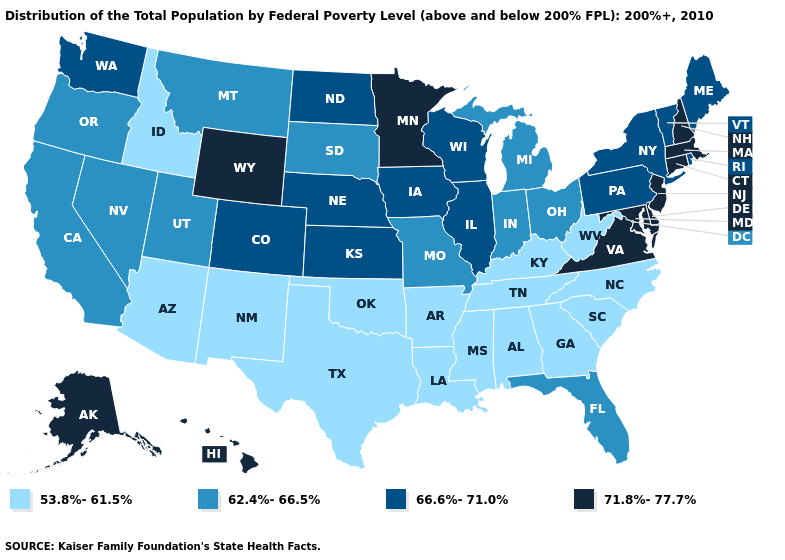Name the states that have a value in the range 66.6%-71.0%?
Give a very brief answer. Colorado, Illinois, Iowa, Kansas, Maine, Nebraska, New York, North Dakota, Pennsylvania, Rhode Island, Vermont, Washington, Wisconsin. Which states have the lowest value in the USA?
Keep it brief. Alabama, Arizona, Arkansas, Georgia, Idaho, Kentucky, Louisiana, Mississippi, New Mexico, North Carolina, Oklahoma, South Carolina, Tennessee, Texas, West Virginia. Does South Carolina have the lowest value in the USA?
Write a very short answer. Yes. What is the value of South Carolina?
Give a very brief answer. 53.8%-61.5%. Does South Dakota have a lower value than Hawaii?
Keep it brief. Yes. Which states hav the highest value in the MidWest?
Quick response, please. Minnesota. Name the states that have a value in the range 66.6%-71.0%?
Keep it brief. Colorado, Illinois, Iowa, Kansas, Maine, Nebraska, New York, North Dakota, Pennsylvania, Rhode Island, Vermont, Washington, Wisconsin. Does Virginia have the lowest value in the South?
Quick response, please. No. Name the states that have a value in the range 71.8%-77.7%?
Short answer required. Alaska, Connecticut, Delaware, Hawaii, Maryland, Massachusetts, Minnesota, New Hampshire, New Jersey, Virginia, Wyoming. Does Nebraska have the lowest value in the MidWest?
Give a very brief answer. No. What is the value of Oklahoma?
Answer briefly. 53.8%-61.5%. Does Nebraska have the highest value in the USA?
Short answer required. No. What is the value of Tennessee?
Quick response, please. 53.8%-61.5%. Is the legend a continuous bar?
Quick response, please. No. 